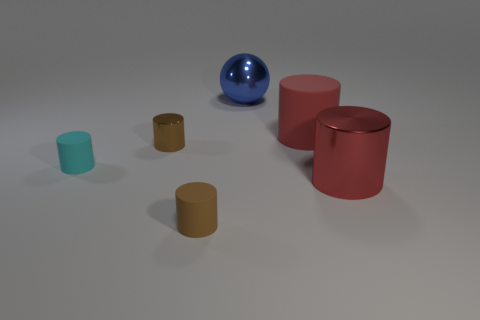How big is the brown cylinder behind the shiny cylinder to the right of the large ball?
Ensure brevity in your answer.  Small. Is the color of the big sphere the same as the tiny shiny object?
Your answer should be compact. No. What number of matte things are brown cylinders or large red cylinders?
Your answer should be compact. 2. How many small matte cylinders are there?
Offer a very short reply. 2. Is the material of the small cyan cylinder to the left of the blue ball the same as the large red cylinder that is behind the tiny brown metallic cylinder?
Provide a short and direct response. Yes. What is the color of the big metallic thing that is the same shape as the cyan matte thing?
Offer a terse response. Red. The brown cylinder that is on the right side of the brown cylinder that is behind the cyan thing is made of what material?
Give a very brief answer. Rubber. There is a metal thing on the right side of the big blue shiny object; is it the same shape as the matte object on the right side of the big blue ball?
Your response must be concise. Yes. There is a matte object that is both behind the red shiny cylinder and left of the blue metal thing; what size is it?
Provide a short and direct response. Small. What number of other objects are the same color as the tiny shiny object?
Offer a terse response. 1. 